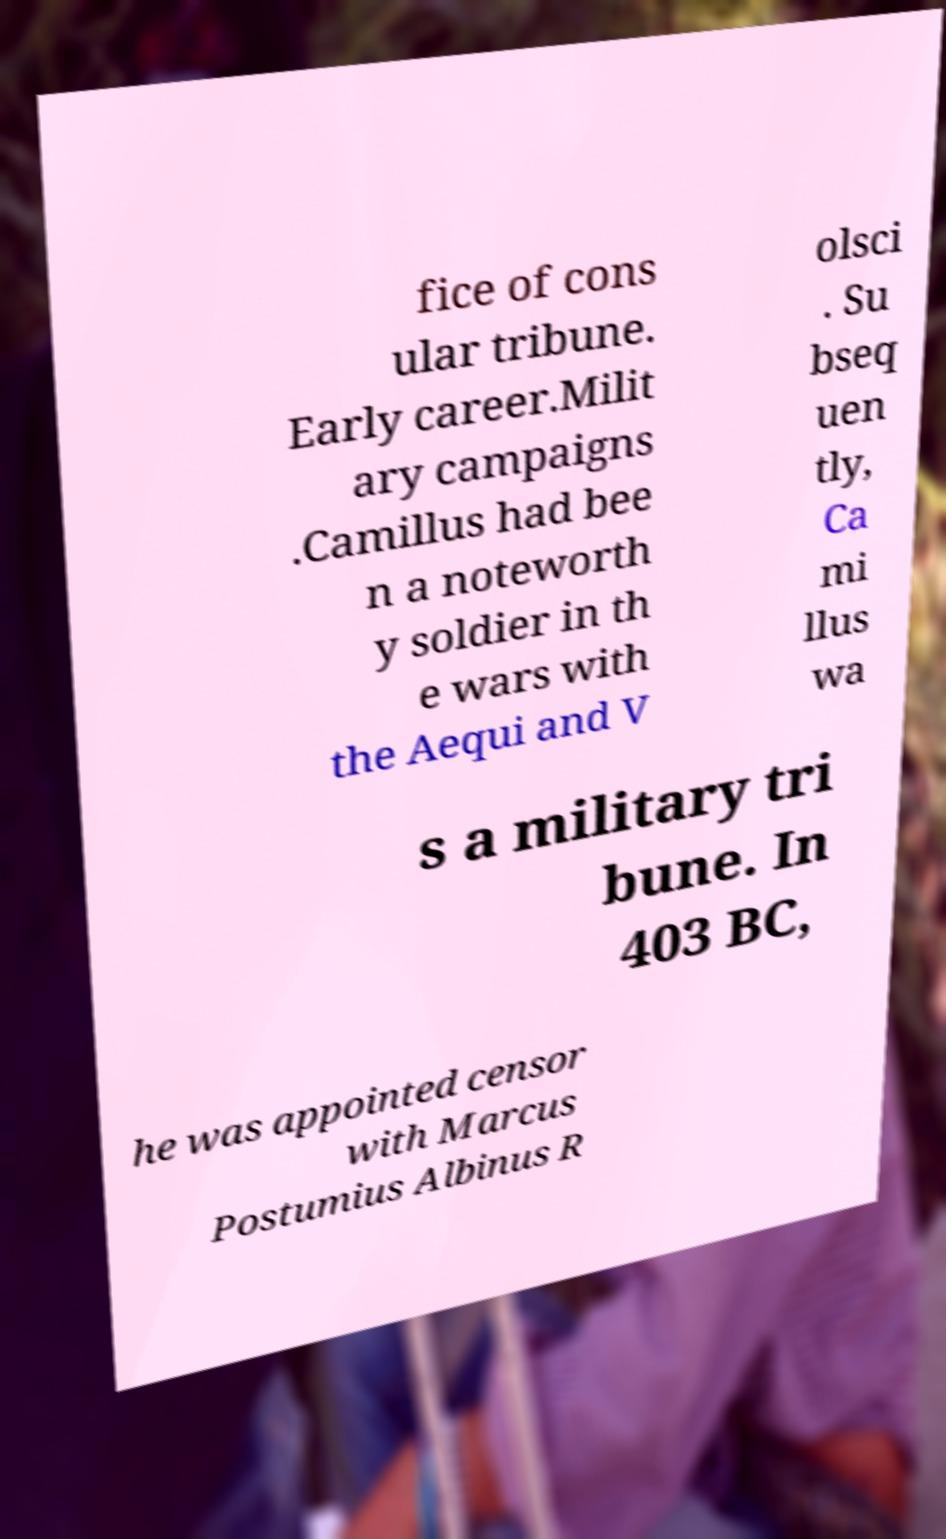Could you assist in decoding the text presented in this image and type it out clearly? fice of cons ular tribune. Early career.Milit ary campaigns .Camillus had bee n a noteworth y soldier in th e wars with the Aequi and V olsci . Su bseq uen tly, Ca mi llus wa s a military tri bune. In 403 BC, he was appointed censor with Marcus Postumius Albinus R 